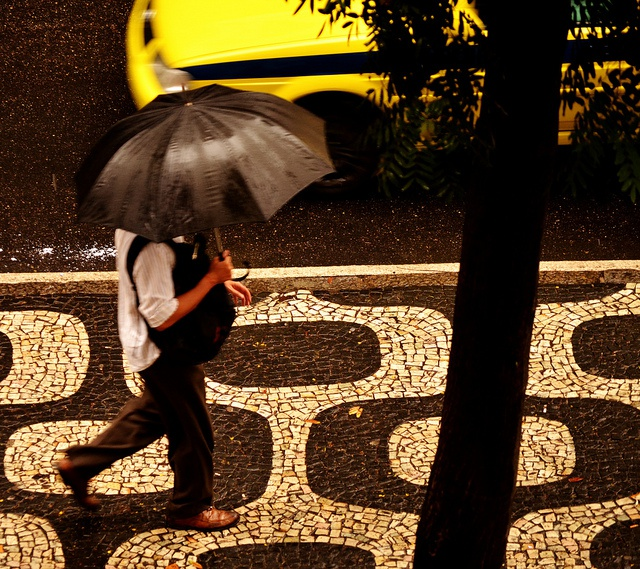Describe the objects in this image and their specific colors. I can see car in black, yellow, orange, and olive tones, umbrella in black, maroon, brown, and gray tones, and backpack in black, tan, and brown tones in this image. 